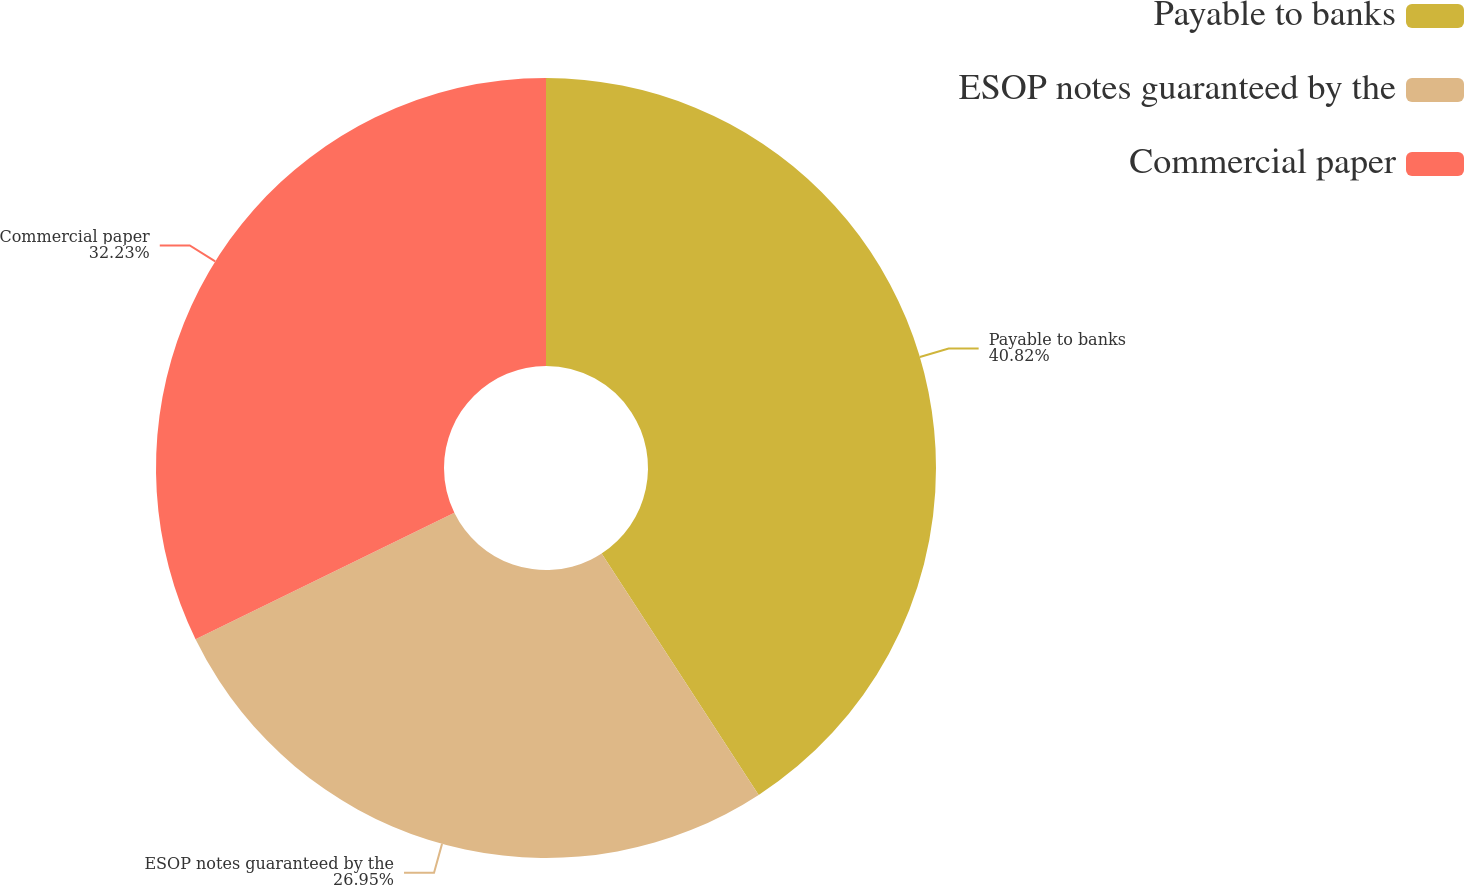Convert chart to OTSL. <chart><loc_0><loc_0><loc_500><loc_500><pie_chart><fcel>Payable to banks<fcel>ESOP notes guaranteed by the<fcel>Commercial paper<nl><fcel>40.82%<fcel>26.95%<fcel>32.23%<nl></chart> 